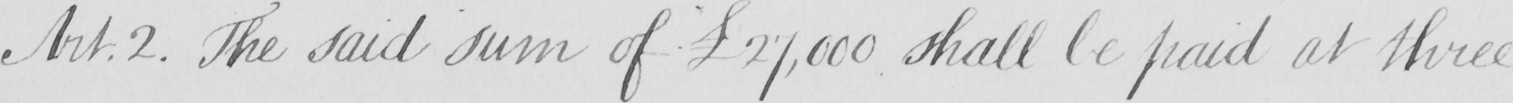Can you tell me what this handwritten text says? The said sum of  £27,000 shall be paid at three 